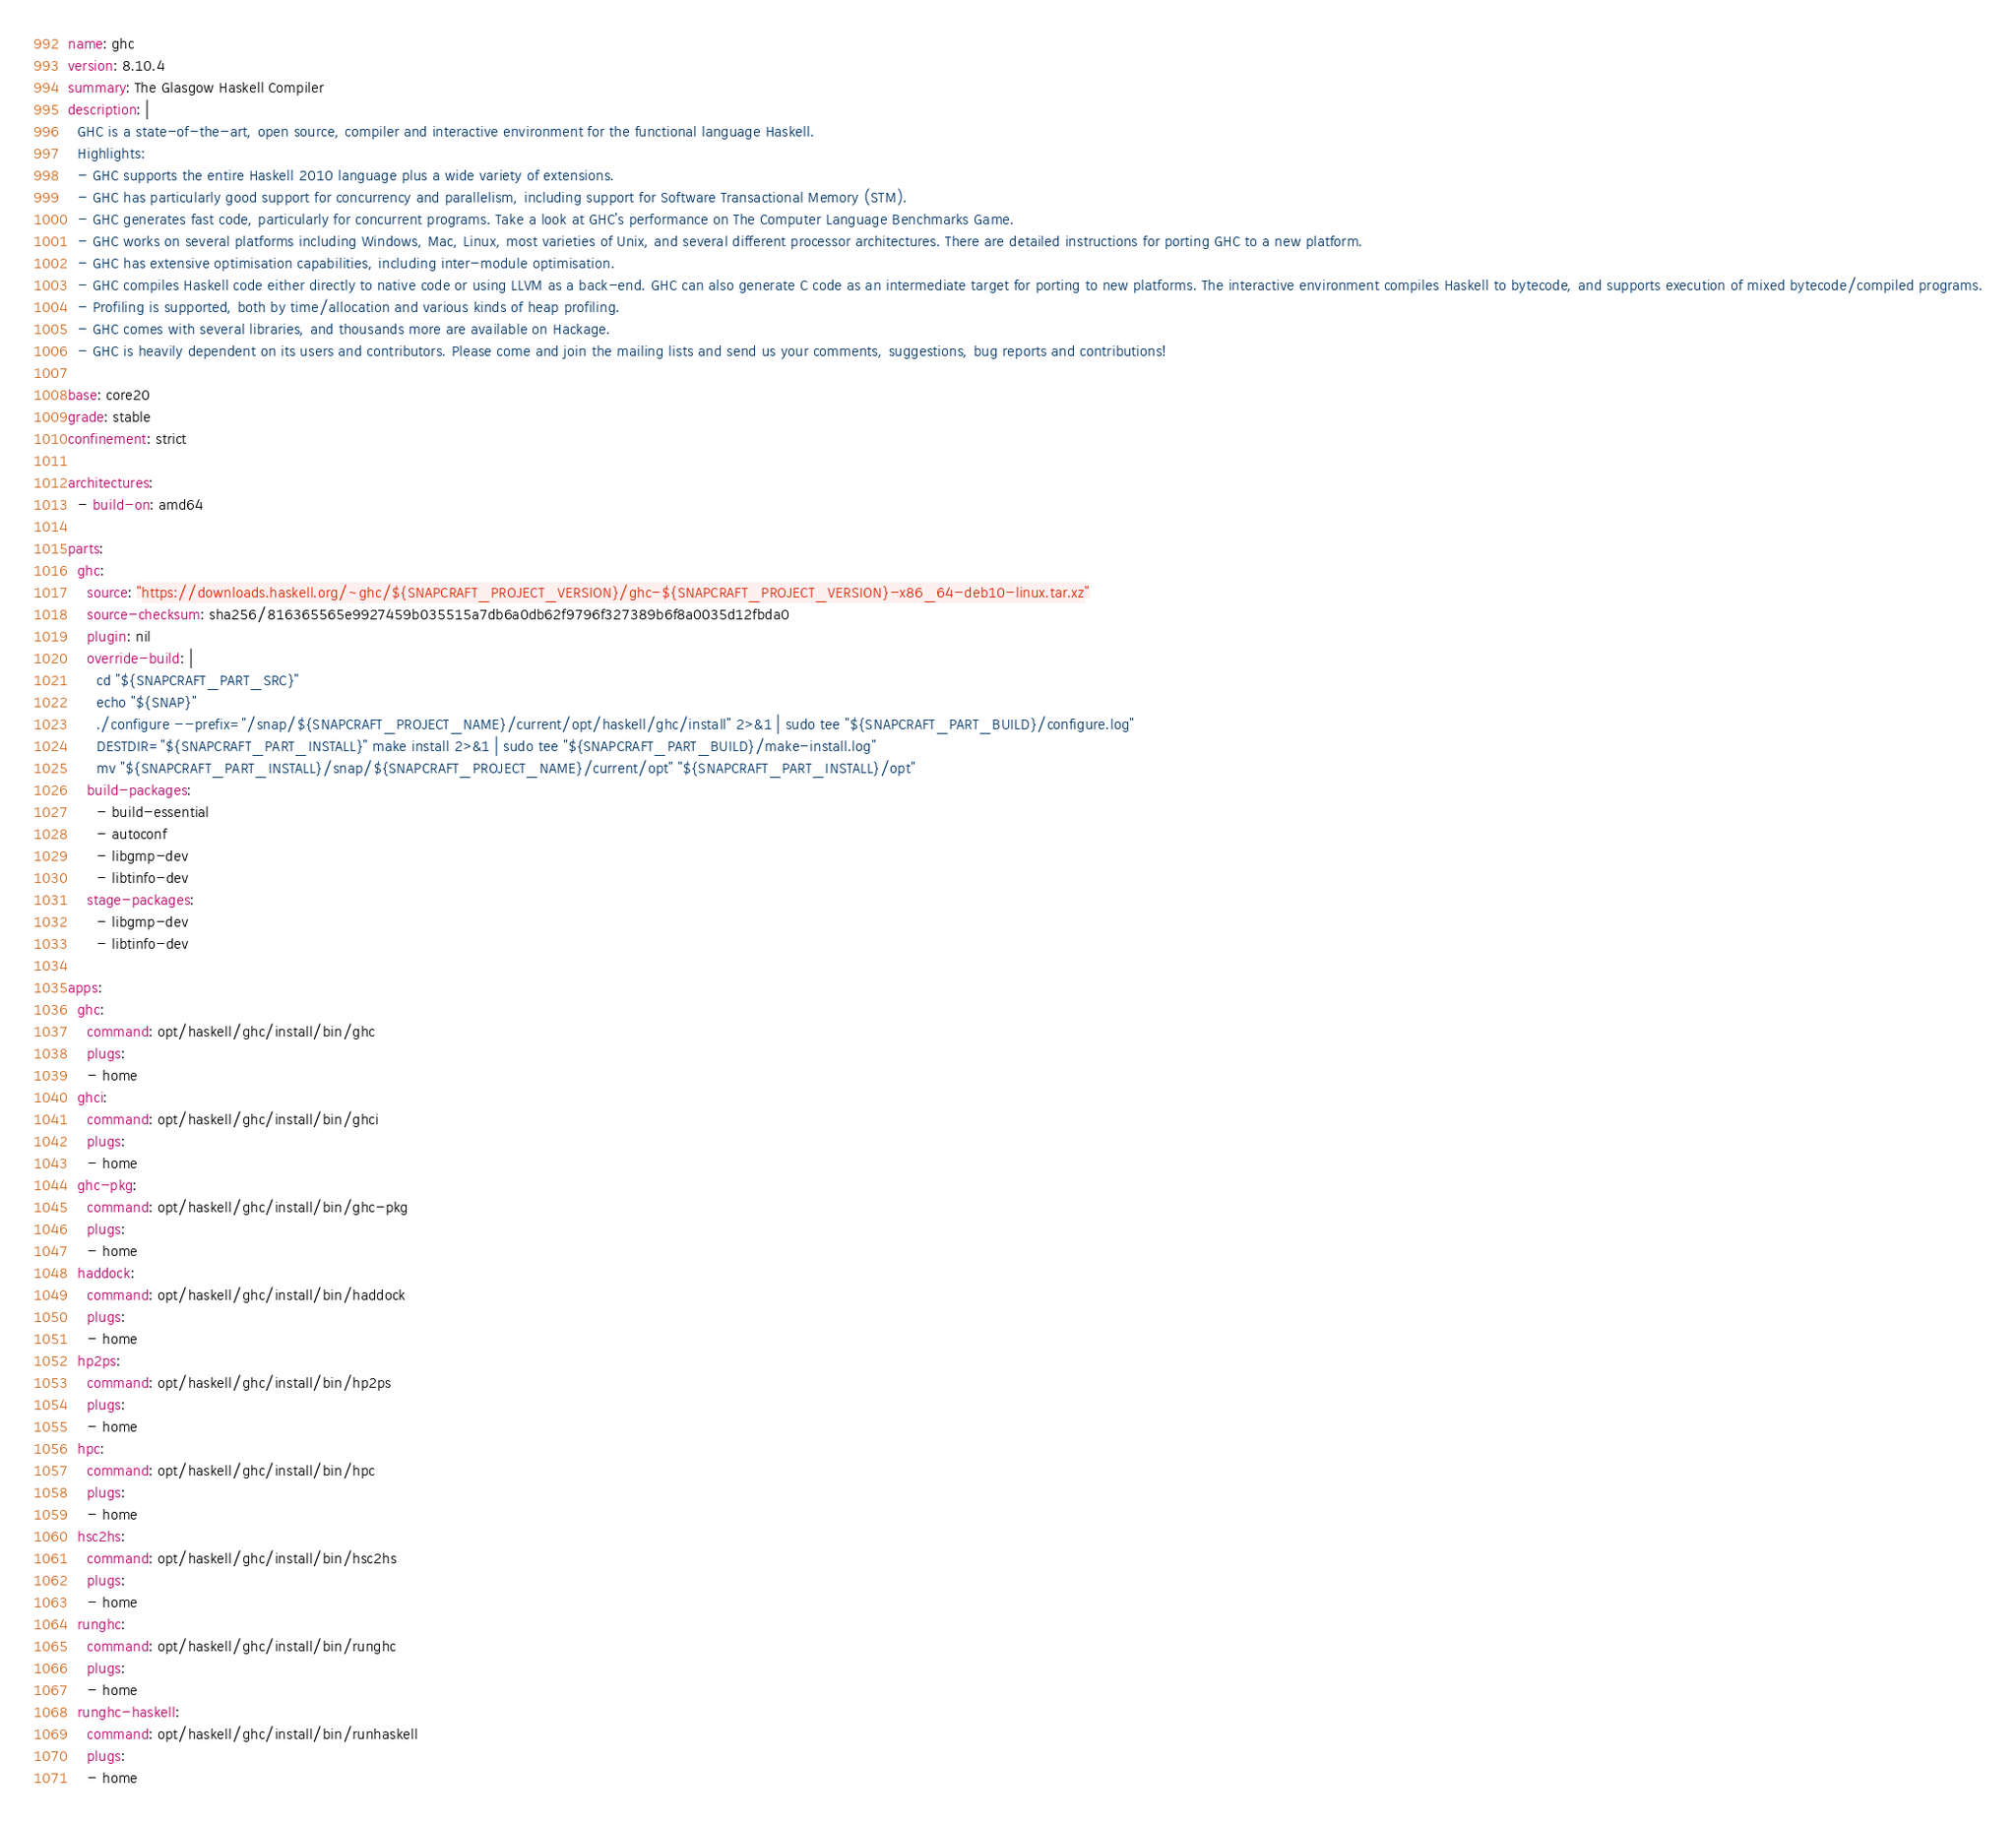Convert code to text. <code><loc_0><loc_0><loc_500><loc_500><_YAML_>name: ghc
version: 8.10.4
summary: The Glasgow Haskell Compiler
description: |
  GHC is a state-of-the-art, open source, compiler and interactive environment for the functional language Haskell.
  Highlights:
  - GHC supports the entire Haskell 2010 language plus a wide variety of extensions.
  - GHC has particularly good support for concurrency and parallelism, including support for Software Transactional Memory (STM).
  - GHC generates fast code, particularly for concurrent programs. Take a look at GHC's performance on The Computer Language Benchmarks Game.
  - GHC works on several platforms including Windows, Mac, Linux, most varieties of Unix, and several different processor architectures. There are detailed instructions for porting GHC to a new platform.
  - GHC has extensive optimisation capabilities, including inter-module optimisation.
  - GHC compiles Haskell code either directly to native code or using LLVM as a back-end. GHC can also generate C code as an intermediate target for porting to new platforms. The interactive environment compiles Haskell to bytecode, and supports execution of mixed bytecode/compiled programs.
  - Profiling is supported, both by time/allocation and various kinds of heap profiling.
  - GHC comes with several libraries, and thousands more are available on Hackage.
  - GHC is heavily dependent on its users and contributors. Please come and join the mailing lists and send us your comments, suggestions, bug reports and contributions!

base: core20
grade: stable
confinement: strict

architectures:
  - build-on: amd64

parts:
  ghc:
    source: "https://downloads.haskell.org/~ghc/${SNAPCRAFT_PROJECT_VERSION}/ghc-${SNAPCRAFT_PROJECT_VERSION}-x86_64-deb10-linux.tar.xz"
    source-checksum: sha256/816365565e9927459b035515a7db6a0db62f9796f327389b6f8a0035d12fbda0
    plugin: nil
    override-build: |
      cd "${SNAPCRAFT_PART_SRC}"
      echo "${SNAP}"
      ./configure --prefix="/snap/${SNAPCRAFT_PROJECT_NAME}/current/opt/haskell/ghc/install" 2>&1 | sudo tee "${SNAPCRAFT_PART_BUILD}/configure.log"
      DESTDIR="${SNAPCRAFT_PART_INSTALL}" make install 2>&1 | sudo tee "${SNAPCRAFT_PART_BUILD}/make-install.log"
      mv "${SNAPCRAFT_PART_INSTALL}/snap/${SNAPCRAFT_PROJECT_NAME}/current/opt" "${SNAPCRAFT_PART_INSTALL}/opt"
    build-packages:
      - build-essential
      - autoconf
      - libgmp-dev
      - libtinfo-dev
    stage-packages:
      - libgmp-dev
      - libtinfo-dev

apps:
  ghc:
    command: opt/haskell/ghc/install/bin/ghc
    plugs:
    - home
  ghci:
    command: opt/haskell/ghc/install/bin/ghci
    plugs:
    - home
  ghc-pkg:
    command: opt/haskell/ghc/install/bin/ghc-pkg
    plugs:
    - home
  haddock:
    command: opt/haskell/ghc/install/bin/haddock
    plugs:
    - home
  hp2ps:
    command: opt/haskell/ghc/install/bin/hp2ps
    plugs:
    - home
  hpc:
    command: opt/haskell/ghc/install/bin/hpc
    plugs:
    - home
  hsc2hs:
    command: opt/haskell/ghc/install/bin/hsc2hs
    plugs:
    - home
  runghc:
    command: opt/haskell/ghc/install/bin/runghc
    plugs:
    - home
  runghc-haskell:
    command: opt/haskell/ghc/install/bin/runhaskell
    plugs:
    - home

</code> 